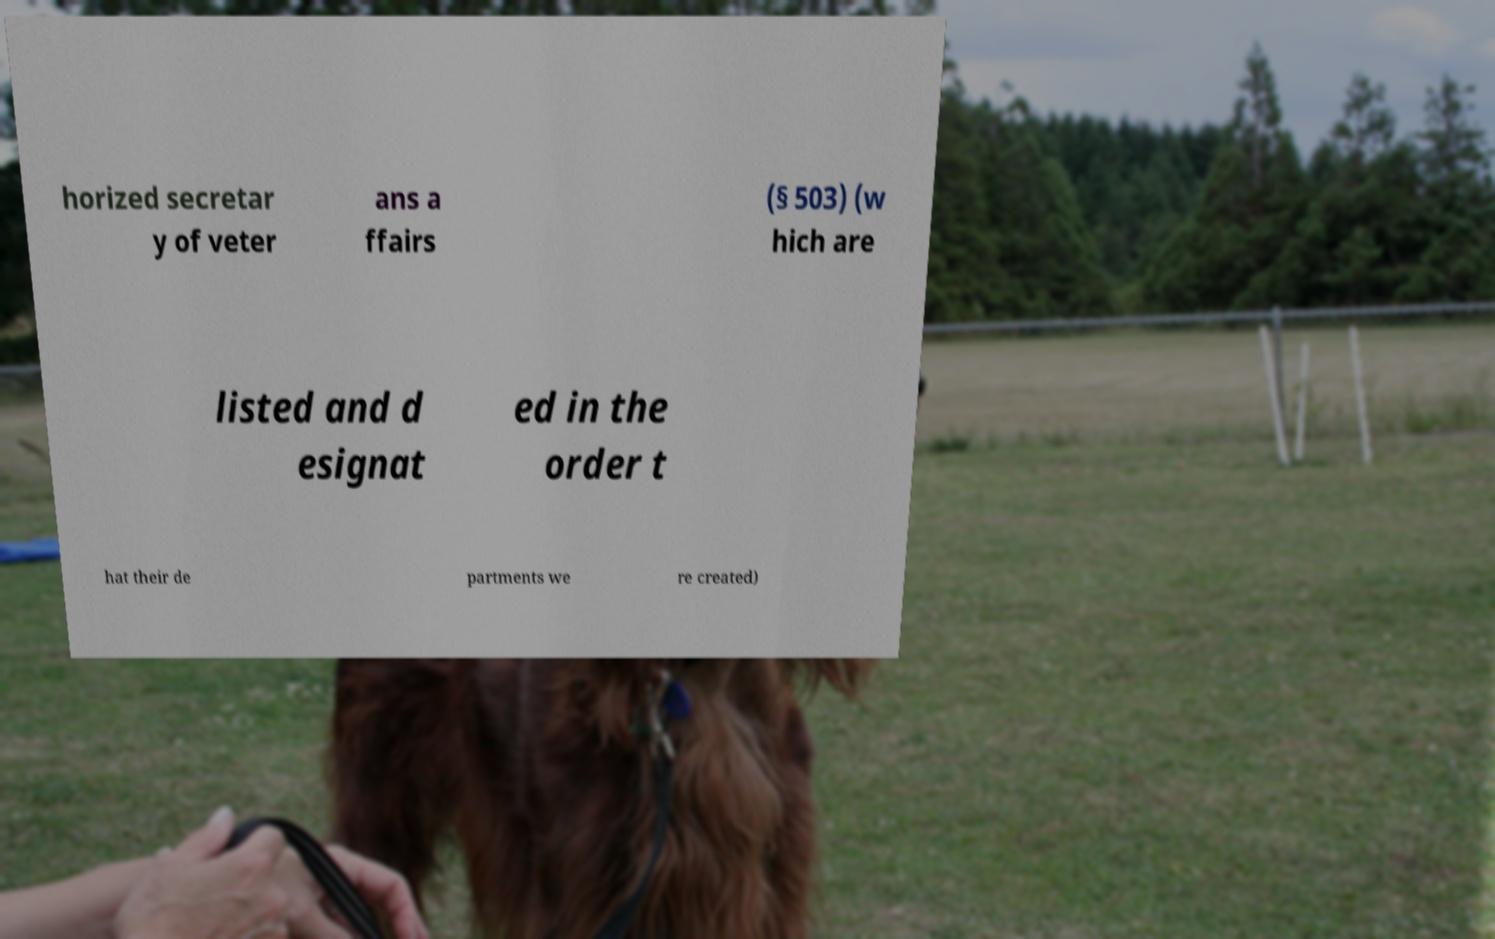Please read and relay the text visible in this image. What does it say? horized secretar y of veter ans a ffairs (§ 503) (w hich are listed and d esignat ed in the order t hat their de partments we re created) 